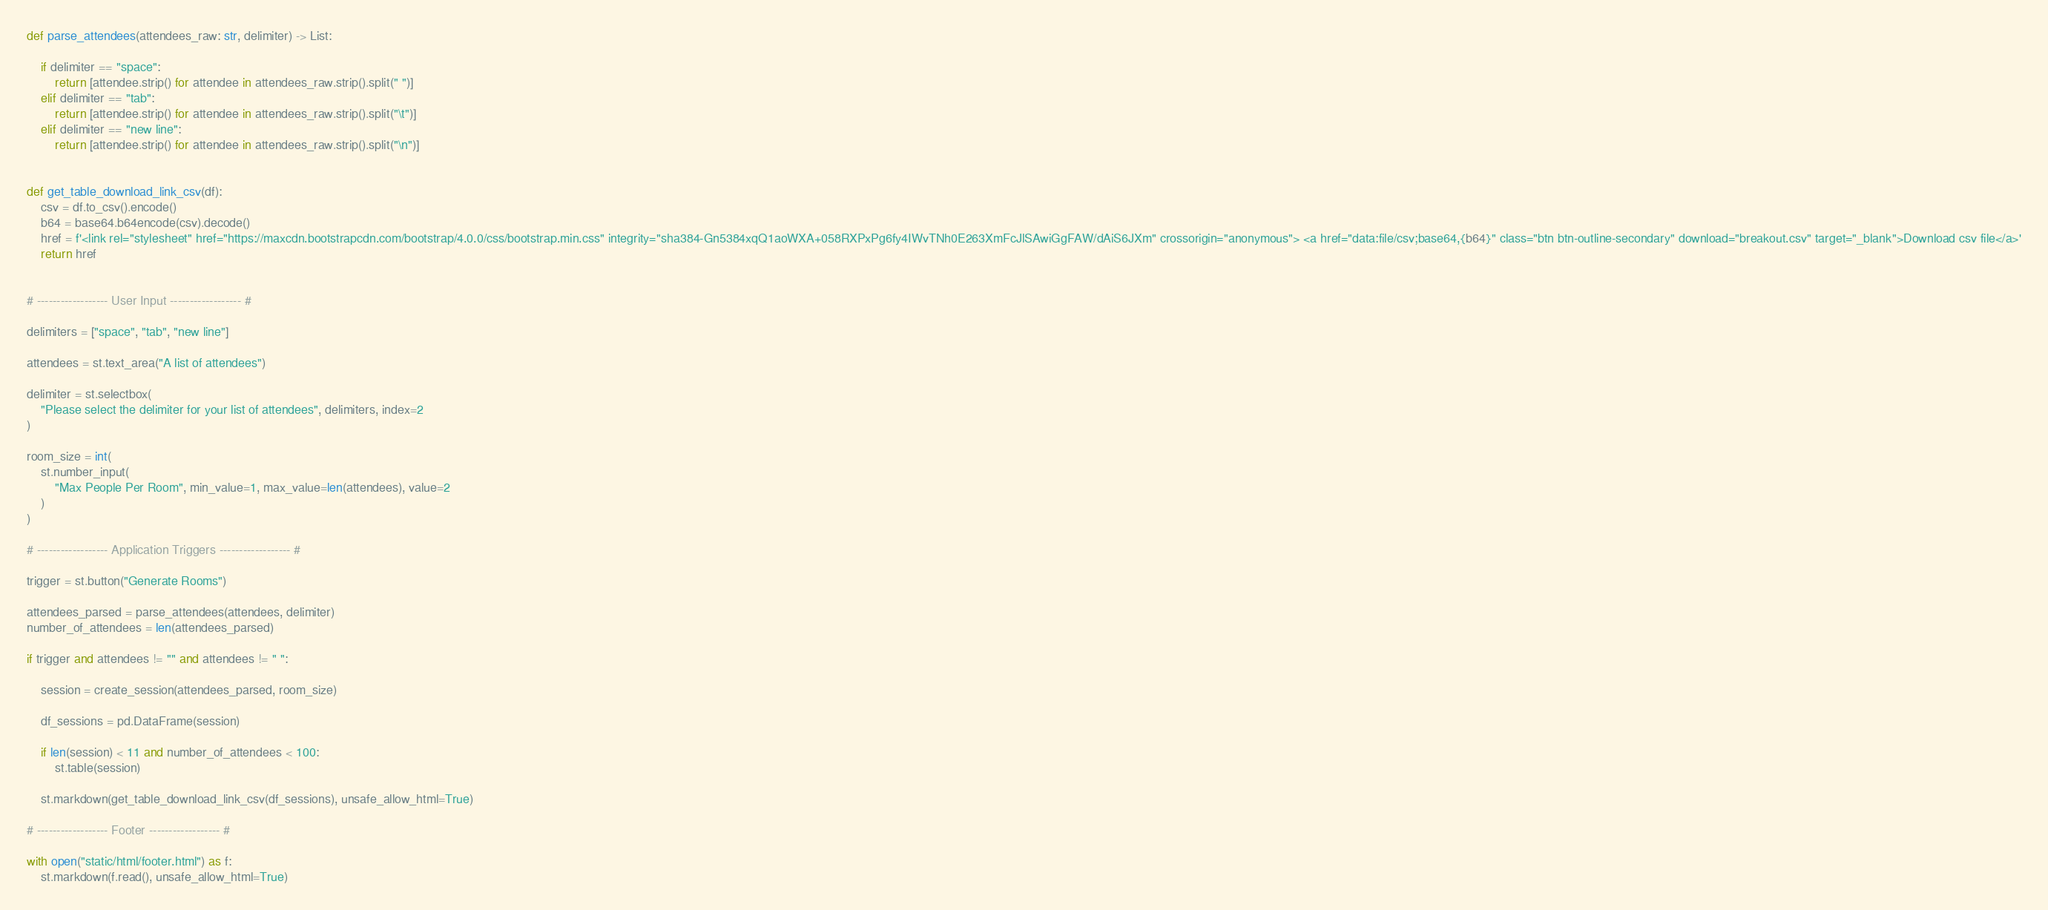Convert code to text. <code><loc_0><loc_0><loc_500><loc_500><_Python_>

def parse_attendees(attendees_raw: str, delimiter) -> List:

    if delimiter == "space":
        return [attendee.strip() for attendee in attendees_raw.strip().split(" ")]
    elif delimiter == "tab":
        return [attendee.strip() for attendee in attendees_raw.strip().split("\t")]
    elif delimiter == "new line":
        return [attendee.strip() for attendee in attendees_raw.strip().split("\n")]


def get_table_download_link_csv(df):
    csv = df.to_csv().encode()
    b64 = base64.b64encode(csv).decode()
    href = f'<link rel="stylesheet" href="https://maxcdn.bootstrapcdn.com/bootstrap/4.0.0/css/bootstrap.min.css" integrity="sha384-Gn5384xqQ1aoWXA+058RXPxPg6fy4IWvTNh0E263XmFcJlSAwiGgFAW/dAiS6JXm" crossorigin="anonymous"> <a href="data:file/csv;base64,{b64}" class="btn btn-outline-secondary" download="breakout.csv" target="_blank">Download csv file</a>'
    return href


# ------------------ User Input ------------------ #

delimiters = ["space", "tab", "new line"]

attendees = st.text_area("A list of attendees")

delimiter = st.selectbox(
    "Please select the delimiter for your list of attendees", delimiters, index=2
)

room_size = int(
    st.number_input(
        "Max People Per Room", min_value=1, max_value=len(attendees), value=2
    )
)

# ------------------ Application Triggers ------------------ #

trigger = st.button("Generate Rooms")

attendees_parsed = parse_attendees(attendees, delimiter)
number_of_attendees = len(attendees_parsed)

if trigger and attendees != "" and attendees != " ":

    session = create_session(attendees_parsed, room_size)

    df_sessions = pd.DataFrame(session)

    if len(session) < 11 and number_of_attendees < 100:
        st.table(session)

    st.markdown(get_table_download_link_csv(df_sessions), unsafe_allow_html=True)

# ------------------ Footer ------------------ #

with open("static/html/footer.html") as f:
    st.markdown(f.read(), unsafe_allow_html=True)
</code> 